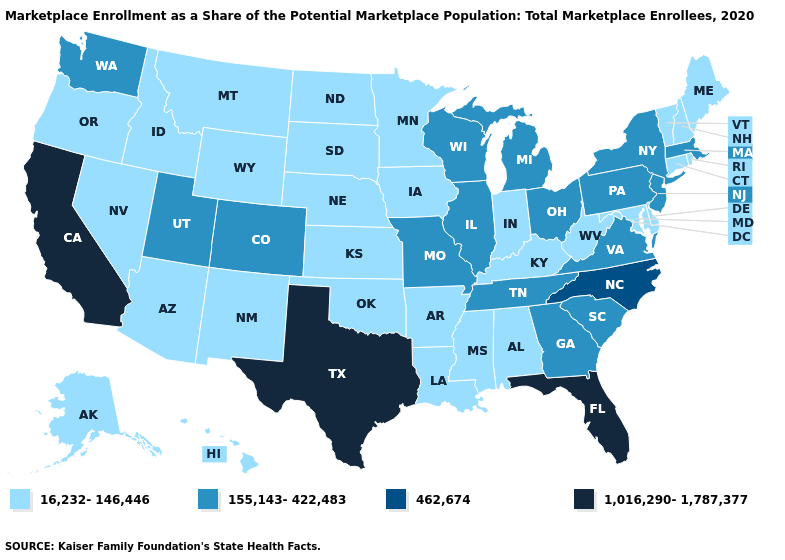What is the value of Missouri?
Answer briefly. 155,143-422,483. Name the states that have a value in the range 16,232-146,446?
Concise answer only. Alabama, Alaska, Arizona, Arkansas, Connecticut, Delaware, Hawaii, Idaho, Indiana, Iowa, Kansas, Kentucky, Louisiana, Maine, Maryland, Minnesota, Mississippi, Montana, Nebraska, Nevada, New Hampshire, New Mexico, North Dakota, Oklahoma, Oregon, Rhode Island, South Dakota, Vermont, West Virginia, Wyoming. Name the states that have a value in the range 462,674?
Be succinct. North Carolina. Does Missouri have a lower value than Louisiana?
Answer briefly. No. What is the value of Michigan?
Answer briefly. 155,143-422,483. Does Utah have the highest value in the West?
Answer briefly. No. Which states have the lowest value in the USA?
Concise answer only. Alabama, Alaska, Arizona, Arkansas, Connecticut, Delaware, Hawaii, Idaho, Indiana, Iowa, Kansas, Kentucky, Louisiana, Maine, Maryland, Minnesota, Mississippi, Montana, Nebraska, Nevada, New Hampshire, New Mexico, North Dakota, Oklahoma, Oregon, Rhode Island, South Dakota, Vermont, West Virginia, Wyoming. What is the highest value in states that border Massachusetts?
Give a very brief answer. 155,143-422,483. Among the states that border Oregon , does California have the lowest value?
Write a very short answer. No. Does the first symbol in the legend represent the smallest category?
Keep it brief. Yes. What is the lowest value in the MidWest?
Concise answer only. 16,232-146,446. Name the states that have a value in the range 1,016,290-1,787,377?
Answer briefly. California, Florida, Texas. Does the first symbol in the legend represent the smallest category?
Quick response, please. Yes. Name the states that have a value in the range 155,143-422,483?
Concise answer only. Colorado, Georgia, Illinois, Massachusetts, Michigan, Missouri, New Jersey, New York, Ohio, Pennsylvania, South Carolina, Tennessee, Utah, Virginia, Washington, Wisconsin. What is the value of Alaska?
Short answer required. 16,232-146,446. 